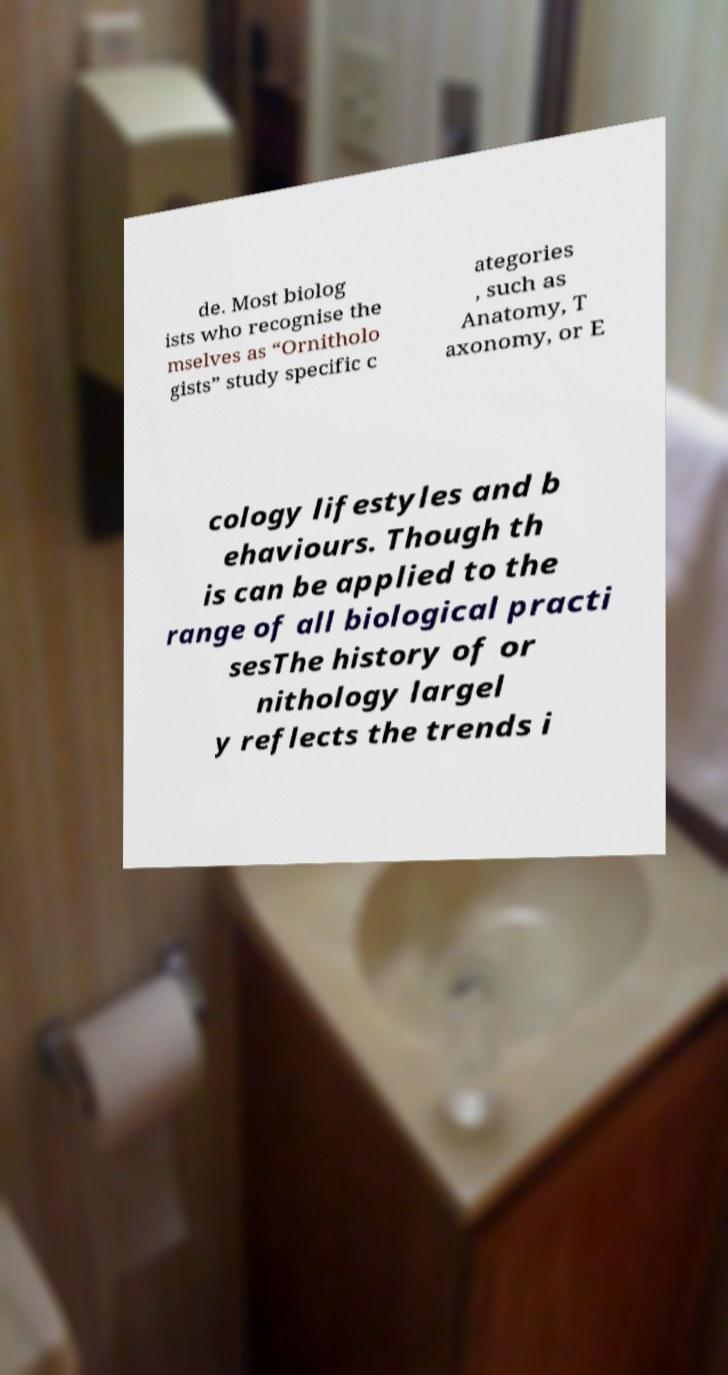I need the written content from this picture converted into text. Can you do that? de. Most biolog ists who recognise the mselves as “Ornitholo gists” study specific c ategories , such as Anatomy, T axonomy, or E cology lifestyles and b ehaviours. Though th is can be applied to the range of all biological practi sesThe history of or nithology largel y reflects the trends i 